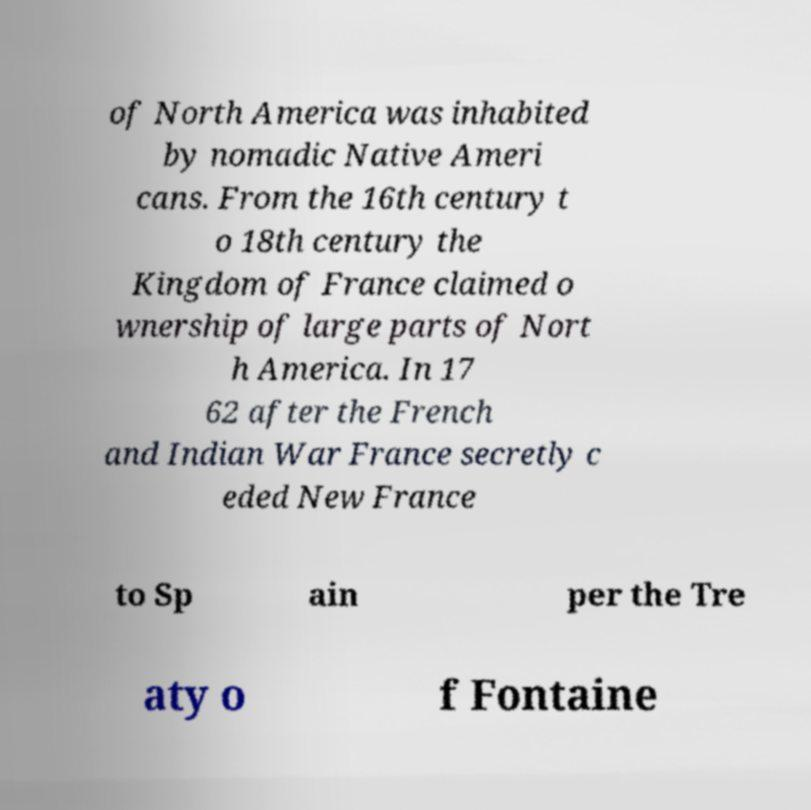There's text embedded in this image that I need extracted. Can you transcribe it verbatim? of North America was inhabited by nomadic Native Ameri cans. From the 16th century t o 18th century the Kingdom of France claimed o wnership of large parts of Nort h America. In 17 62 after the French and Indian War France secretly c eded New France to Sp ain per the Tre aty o f Fontaine 